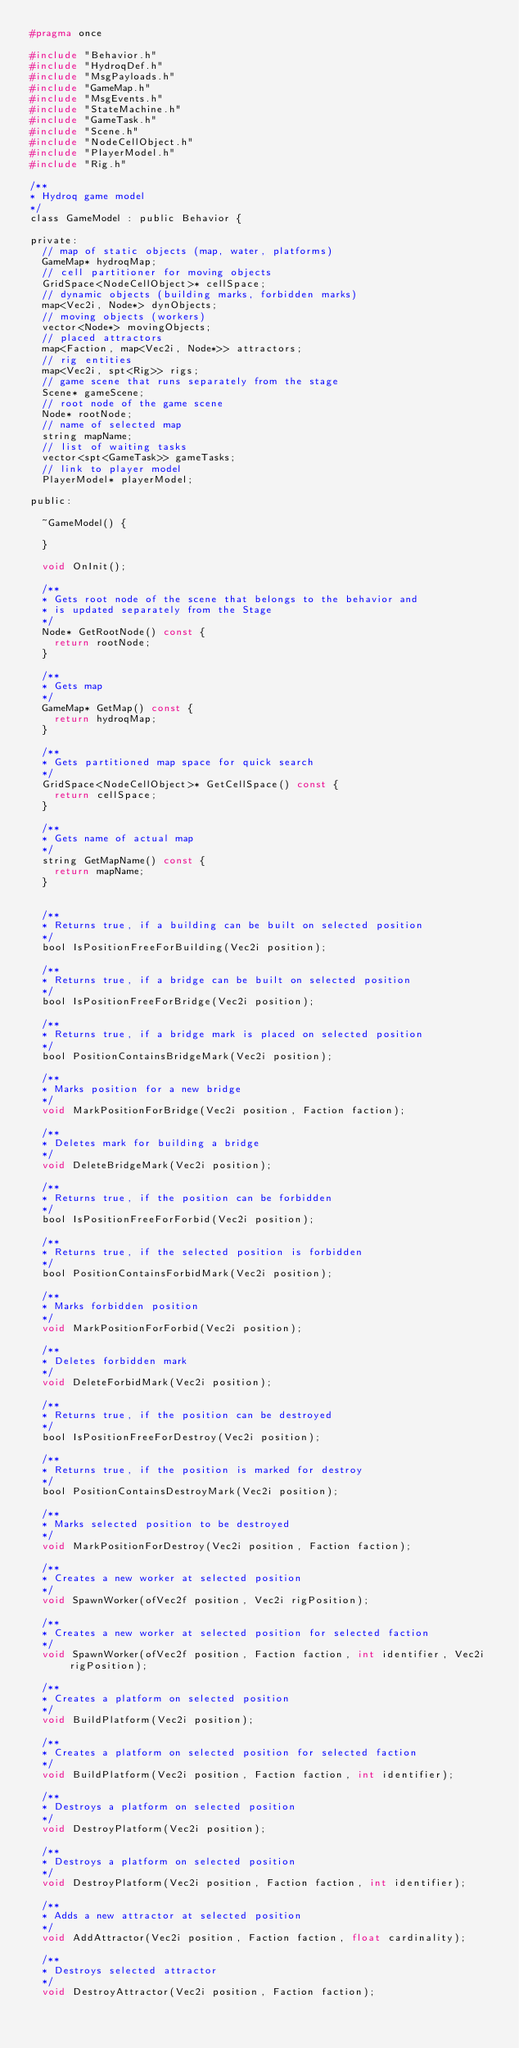<code> <loc_0><loc_0><loc_500><loc_500><_C_>#pragma once

#include "Behavior.h"
#include "HydroqDef.h"
#include "MsgPayloads.h"
#include "GameMap.h"
#include "MsgEvents.h"
#include "StateMachine.h"
#include "GameTask.h"
#include "Scene.h"
#include "NodeCellObject.h"
#include "PlayerModel.h"
#include "Rig.h"

/**
* Hydroq game model
*/
class GameModel : public Behavior {

private:
	// map of static objects (map, water, platforms)
	GameMap* hydroqMap;
	// cell partitioner for moving objects
	GridSpace<NodeCellObject>* cellSpace;
	// dynamic objects (building marks, forbidden marks)
	map<Vec2i, Node*> dynObjects;
	// moving objects (workers)
	vector<Node*> movingObjects;
	// placed attractors
	map<Faction, map<Vec2i, Node*>> attractors;
	// rig entities
	map<Vec2i, spt<Rig>> rigs;
	// game scene that runs separately from the stage
	Scene* gameScene;
	// root node of the game scene
	Node* rootNode;
	// name of selected map
	string mapName;
	// list of waiting tasks
	vector<spt<GameTask>> gameTasks;
	// link to player model
	PlayerModel* playerModel;

public:

	~GameModel() {

	}

	void OnInit();

	/**
	* Gets root node of the scene that belongs to the behavior and
	* is updated separately from the Stage
	*/
	Node* GetRootNode() const {
		return rootNode;
	}

	/**
	* Gets map
	*/
	GameMap* GetMap() const {
		return hydroqMap;
	}

	/**
	* Gets partitioned map space for quick search
	*/
	GridSpace<NodeCellObject>* GetCellSpace() const {
		return cellSpace;
	}

	/**
	* Gets name of actual map
	*/
	string GetMapName() const {
		return mapName;
	}


	/**
	* Returns true, if a building can be built on selected position
	*/
	bool IsPositionFreeForBuilding(Vec2i position);

	/**
	* Returns true, if a bridge can be built on selected position
	*/
	bool IsPositionFreeForBridge(Vec2i position);

	/**
	* Returns true, if a bridge mark is placed on selected position
	*/
	bool PositionContainsBridgeMark(Vec2i position);
	
	/**
	* Marks position for a new bridge
	*/
	void MarkPositionForBridge(Vec2i position, Faction faction);

	/**
	* Deletes mark for building a bridge
	*/
	void DeleteBridgeMark(Vec2i position);

	/**
	* Returns true, if the position can be forbidden
	*/
	bool IsPositionFreeForForbid(Vec2i position);

	/**
	* Returns true, if the selected position is forbidden
	*/
	bool PositionContainsForbidMark(Vec2i position);

	/**
	* Marks forbidden position
	*/
	void MarkPositionForForbid(Vec2i position);

	/**
	* Deletes forbidden mark
	*/
	void DeleteForbidMark(Vec2i position);

	/**
	* Returns true, if the position can be destroyed
	*/
	bool IsPositionFreeForDestroy(Vec2i position);

	/**
	* Returns true, if the position is marked for destroy
	*/
	bool PositionContainsDestroyMark(Vec2i position);

	/**
	* Marks selected position to be destroyed
	*/
	void MarkPositionForDestroy(Vec2i position, Faction faction);

	/**
	* Creates a new worker at selected position
	*/
	void SpawnWorker(ofVec2f position, Vec2i rigPosition);

	/**
	* Creates a new worker at selected position for selected faction
	*/
	void SpawnWorker(ofVec2f position, Faction faction, int identifier, Vec2i rigPosition);

	/**
	* Creates a platform on selected position
	*/
	void BuildPlatform(Vec2i position);

	/**
	* Creates a platform on selected position for selected faction
	*/
	void BuildPlatform(Vec2i position, Faction faction, int identifier);

	/**
	* Destroys a platform on selected position
	*/
	void DestroyPlatform(Vec2i position);

	/**
	* Destroys a platform on selected position
	*/
	void DestroyPlatform(Vec2i position, Faction faction, int identifier);

	/**
	* Adds a new attractor at selected position
	*/
	void AddAttractor(Vec2i position, Faction faction, float cardinality);

	/**
	* Destroys selected attractor
	*/
	void DestroyAttractor(Vec2i position, Faction faction);
</code> 